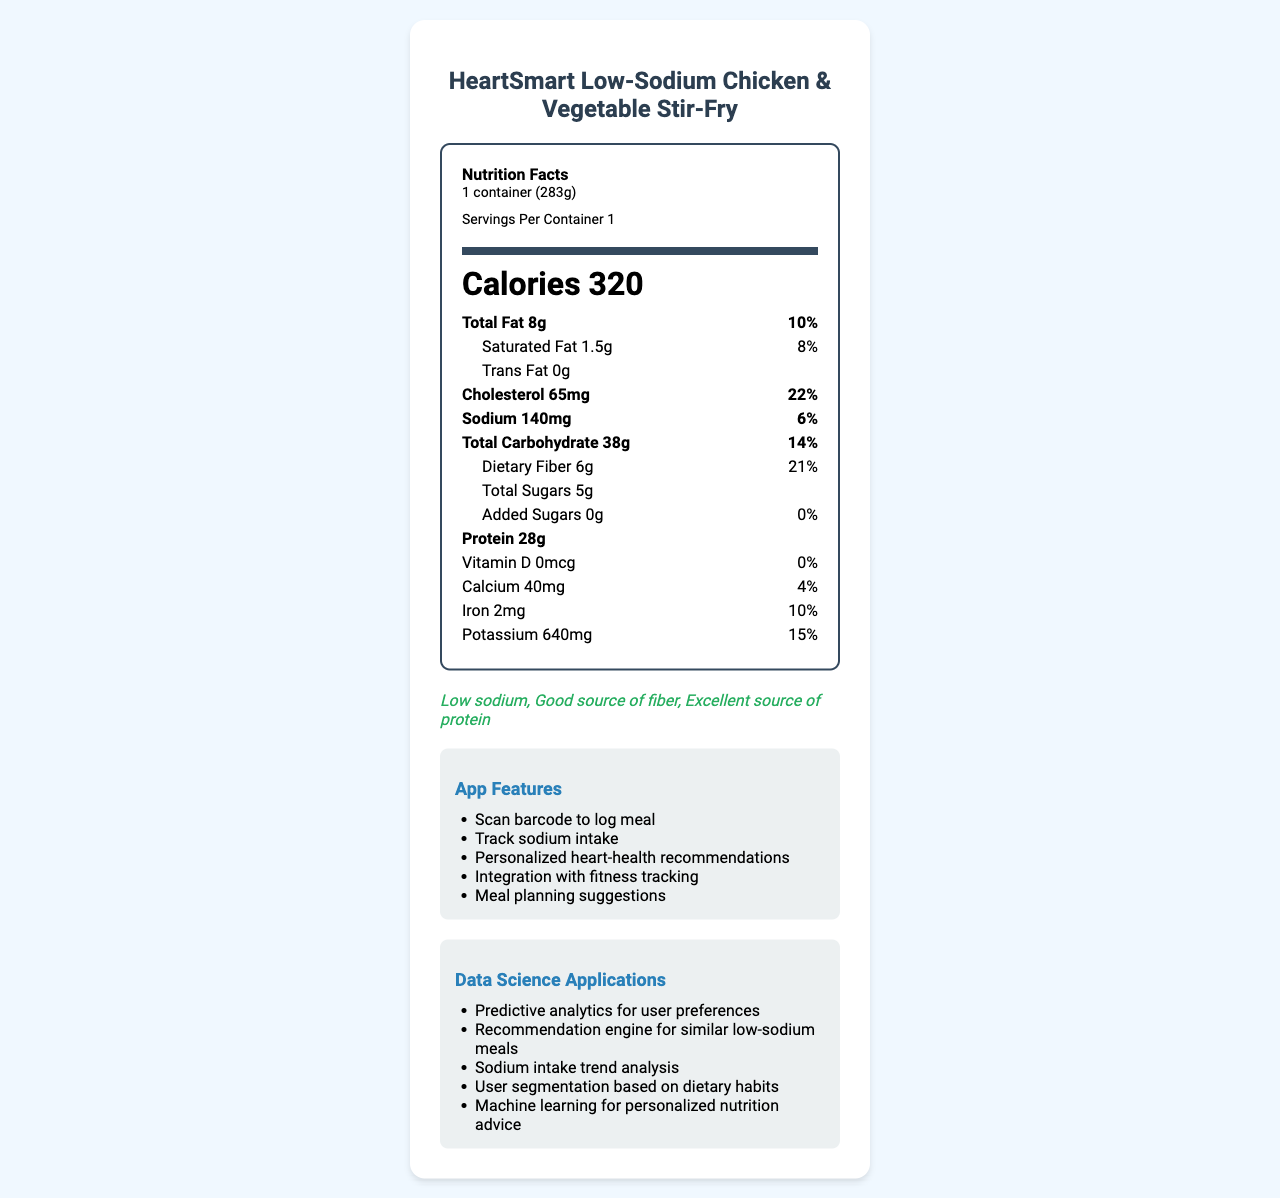what is the serving size for this meal? The serving size is indicated at the top of the Nutrition Facts label as "1 container (283g)".
Answer: 1 container (283g) how many calories are in one serving of the HeartSmart Low-Sodium Chicken & Vegetable Stir-Fry? The number of calories is specified directly in the nutrition label as 320.
Answer: 320 what is the total amount of fat per serving, and what percentage of the daily value does it represent? The nutrition label shows the total amount of fat as 8g, which represents 10% of the daily value.
Answer: 8g, 10% how much sodium does one serving of this meal contain? The amount of sodium per serving is listed as 140mg on the nutrition label.
Answer: 140mg what are the main ingredients in the HeartSmart Low-Sodium Chicken & Vegetable Stir-Fry? The main ingredients are listed at the bottom of the document in the ingredients section.
Answer: Grilled chicken breast, Brown rice, Broccoli, Carrots, Bell peppers, Water chestnuts, Olive oil, Garlic, Ginger, Low-sodium soy sauce, Cornstarch, Black pepper what percentage of the daily value of dietary fiber does one serving provide? The document states that one serving provides 21% of the daily value for dietary fiber.
Answer: 21% how many grams of protein are in one serving of this meal? A. 10g B. 15g C. 28g D. 30g The nutrition label indicates that one serving contains 28g of protein.
Answer: C which of the following is a health claim made by this product? A. Low fat B. High sugar C. Low sodium D. High sodium Among the listed options, "Low sodium" is the correct health claim as mentioned at the bottom of the document.
Answer: C does this meal contain any trans fat? The nutrition label states that the amount of trans fat is 0g, indicating that there is no trans fat in the meal.
Answer: No provide a summary of this document. The summary captures the key details and functionalities presented in the document, including nutrition information, ingredients, health claims, app features, and data science applications.
Answer: The document describes the nutrition facts, ingredients, and health claims of the HeartSmart Low-Sodium Chicken & Vegetable Stir-Fry, a single-serving meal with 320 calories and 140mg of sodium. It emphasizes being low-sodium and heart-healthy. Additionally, it lists various app features and potential data science applications relevant to the product. what is the percentage of daily value for cholesterol provided by this meal? The nutrition label indicates that the cholesterol content per serving is 65mg, which is 22% of the daily value.
Answer: 22% can you determine the total amount of sugars present beyond naturally occurring sugars? The label lists total sugars as 5g and added sugars as 0g, but without information on other types of sugars, the total amount of "beyond naturally occurring sugars" cannot be precisely determined from the document.
Answer: Cannot be determined based on the document, is this meal a good source of fiber? The health claims section at the bottom of the document lists "Good source of fiber" as one of its attributes.
Answer: Yes how much potassium does one serving of this meal contain? The amount of potassium is listed on the nutrition label as 640mg.
Answer: 640mg which app feature allows users to input the meal information directly? A. Track sodium intake B. Meal planning suggestions C. Scan barcode to log meal D. Integration with fitness tracking The app feature "Scan barcode to log meal" allows users to input the meal information directly.
Answer: C are there any allergens present in the ingredients list for this meal? If so, what are they? The allergens listed in the document include "Soy".
Answer: Yes, Soy 